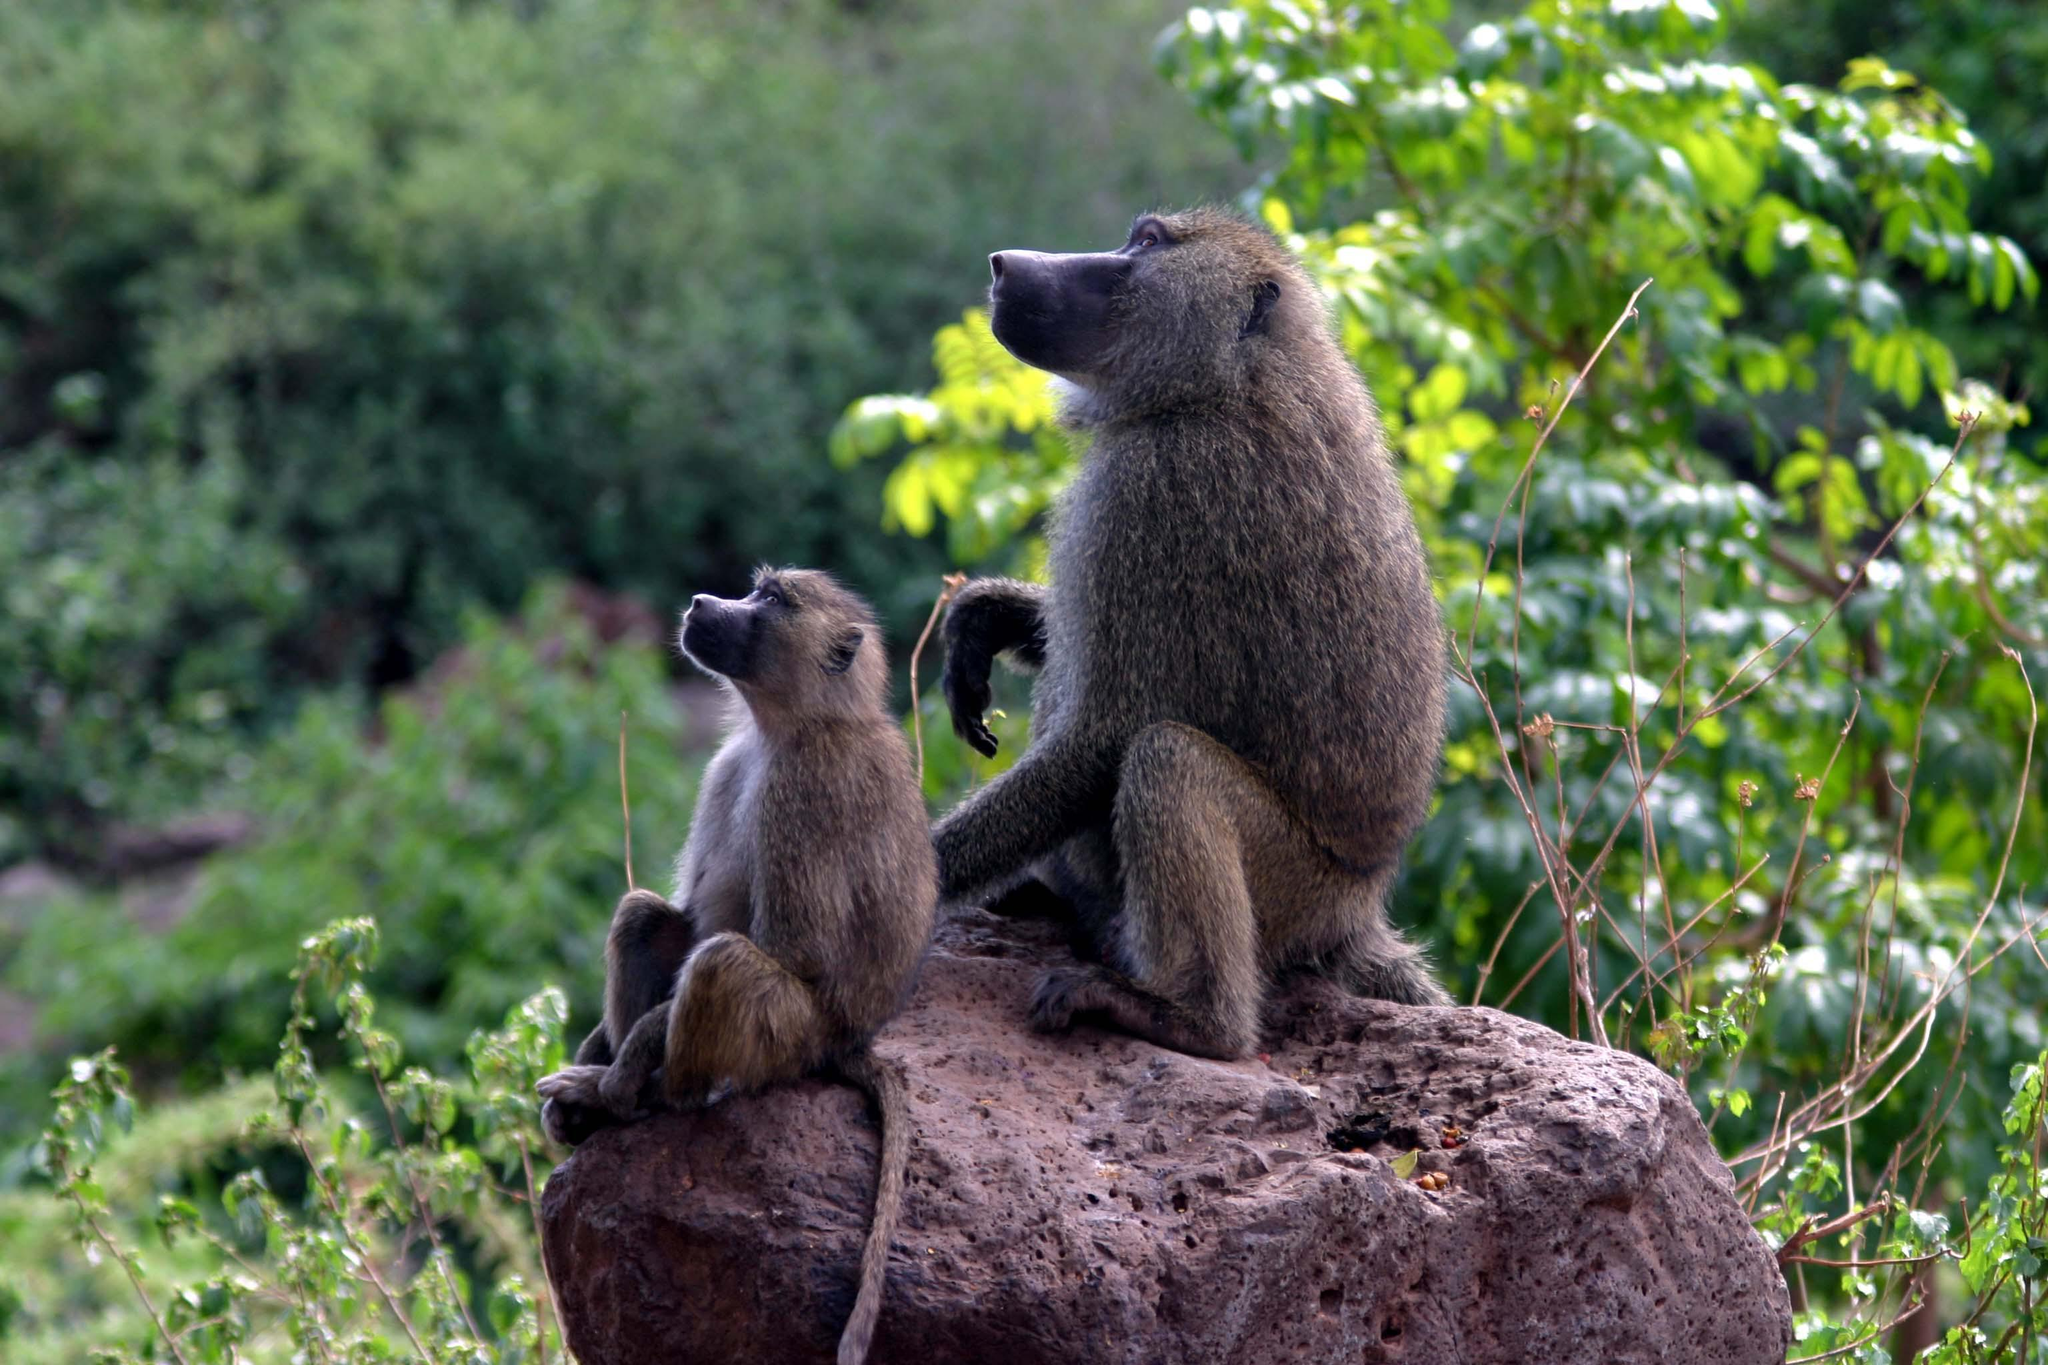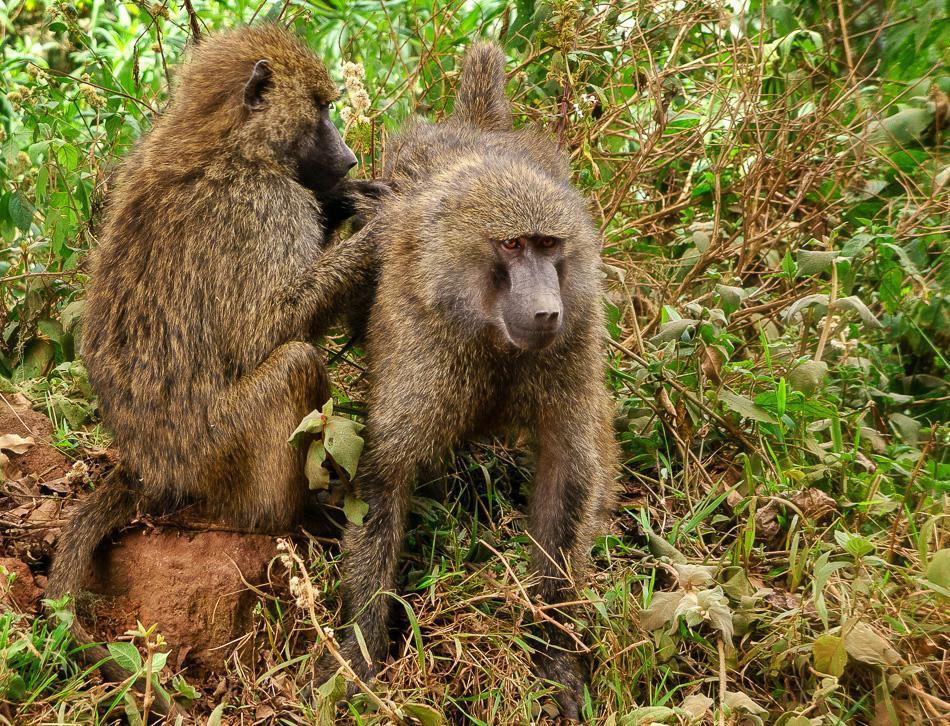The first image is the image on the left, the second image is the image on the right. Considering the images on both sides, is "No more than 2 baboons in either picture." valid? Answer yes or no. Yes. 